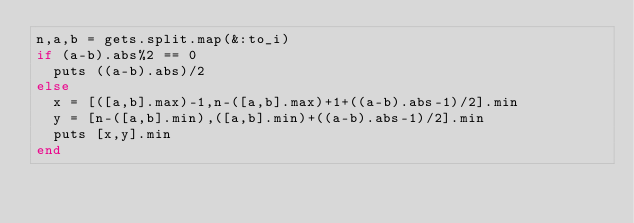Convert code to text. <code><loc_0><loc_0><loc_500><loc_500><_Ruby_>n,a,b = gets.split.map(&:to_i)
if (a-b).abs%2 == 0
  puts ((a-b).abs)/2
else
  x = [([a,b].max)-1,n-([a,b].max)+1+((a-b).abs-1)/2].min
  y = [n-([a,b].min),([a,b].min)+((a-b).abs-1)/2].min
  puts [x,y].min
end</code> 